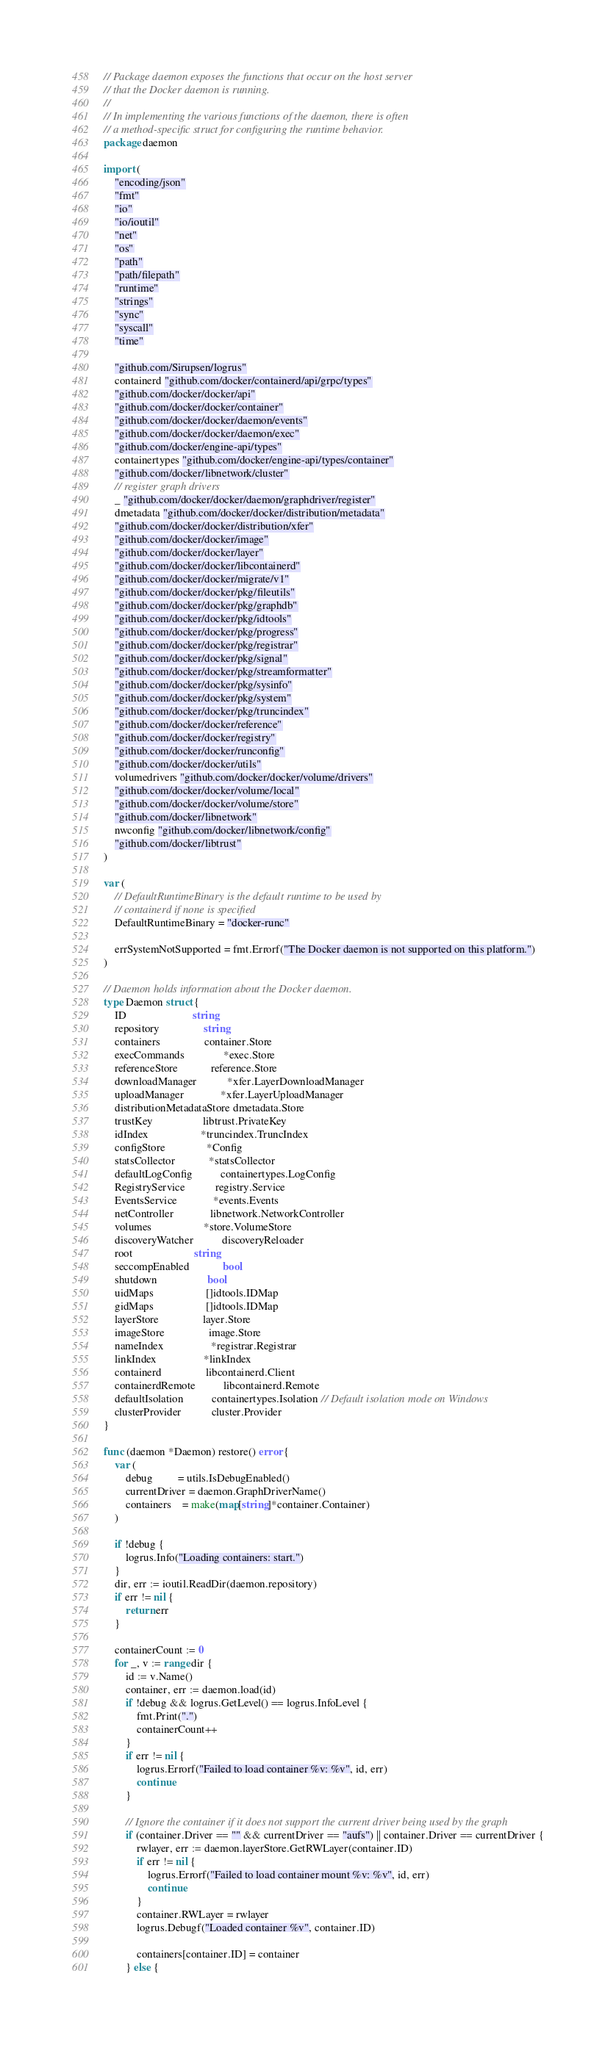<code> <loc_0><loc_0><loc_500><loc_500><_Go_>// Package daemon exposes the functions that occur on the host server
// that the Docker daemon is running.
//
// In implementing the various functions of the daemon, there is often
// a method-specific struct for configuring the runtime behavior.
package daemon

import (
	"encoding/json"
	"fmt"
	"io"
	"io/ioutil"
	"net"
	"os"
	"path"
	"path/filepath"
	"runtime"
	"strings"
	"sync"
	"syscall"
	"time"

	"github.com/Sirupsen/logrus"
	containerd "github.com/docker/containerd/api/grpc/types"
	"github.com/docker/docker/api"
	"github.com/docker/docker/container"
	"github.com/docker/docker/daemon/events"
	"github.com/docker/docker/daemon/exec"
	"github.com/docker/engine-api/types"
	containertypes "github.com/docker/engine-api/types/container"
	"github.com/docker/libnetwork/cluster"
	// register graph drivers
	_ "github.com/docker/docker/daemon/graphdriver/register"
	dmetadata "github.com/docker/docker/distribution/metadata"
	"github.com/docker/docker/distribution/xfer"
	"github.com/docker/docker/image"
	"github.com/docker/docker/layer"
	"github.com/docker/docker/libcontainerd"
	"github.com/docker/docker/migrate/v1"
	"github.com/docker/docker/pkg/fileutils"
	"github.com/docker/docker/pkg/graphdb"
	"github.com/docker/docker/pkg/idtools"
	"github.com/docker/docker/pkg/progress"
	"github.com/docker/docker/pkg/registrar"
	"github.com/docker/docker/pkg/signal"
	"github.com/docker/docker/pkg/streamformatter"
	"github.com/docker/docker/pkg/sysinfo"
	"github.com/docker/docker/pkg/system"
	"github.com/docker/docker/pkg/truncindex"
	"github.com/docker/docker/reference"
	"github.com/docker/docker/registry"
	"github.com/docker/docker/runconfig"
	"github.com/docker/docker/utils"
	volumedrivers "github.com/docker/docker/volume/drivers"
	"github.com/docker/docker/volume/local"
	"github.com/docker/docker/volume/store"
	"github.com/docker/libnetwork"
	nwconfig "github.com/docker/libnetwork/config"
	"github.com/docker/libtrust"
)

var (
	// DefaultRuntimeBinary is the default runtime to be used by
	// containerd if none is specified
	DefaultRuntimeBinary = "docker-runc"

	errSystemNotSupported = fmt.Errorf("The Docker daemon is not supported on this platform.")
)

// Daemon holds information about the Docker daemon.
type Daemon struct {
	ID                        string
	repository                string
	containers                container.Store
	execCommands              *exec.Store
	referenceStore            reference.Store
	downloadManager           *xfer.LayerDownloadManager
	uploadManager             *xfer.LayerUploadManager
	distributionMetadataStore dmetadata.Store
	trustKey                  libtrust.PrivateKey
	idIndex                   *truncindex.TruncIndex
	configStore               *Config
	statsCollector            *statsCollector
	defaultLogConfig          containertypes.LogConfig
	RegistryService           registry.Service
	EventsService             *events.Events
	netController             libnetwork.NetworkController
	volumes                   *store.VolumeStore
	discoveryWatcher          discoveryReloader
	root                      string
	seccompEnabled            bool
	shutdown                  bool
	uidMaps                   []idtools.IDMap
	gidMaps                   []idtools.IDMap
	layerStore                layer.Store
	imageStore                image.Store
	nameIndex                 *registrar.Registrar
	linkIndex                 *linkIndex
	containerd                libcontainerd.Client
	containerdRemote          libcontainerd.Remote
	defaultIsolation          containertypes.Isolation // Default isolation mode on Windows
	clusterProvider           cluster.Provider
}

func (daemon *Daemon) restore() error {
	var (
		debug         = utils.IsDebugEnabled()
		currentDriver = daemon.GraphDriverName()
		containers    = make(map[string]*container.Container)
	)

	if !debug {
		logrus.Info("Loading containers: start.")
	}
	dir, err := ioutil.ReadDir(daemon.repository)
	if err != nil {
		return err
	}

	containerCount := 0
	for _, v := range dir {
		id := v.Name()
		container, err := daemon.load(id)
		if !debug && logrus.GetLevel() == logrus.InfoLevel {
			fmt.Print(".")
			containerCount++
		}
		if err != nil {
			logrus.Errorf("Failed to load container %v: %v", id, err)
			continue
		}

		// Ignore the container if it does not support the current driver being used by the graph
		if (container.Driver == "" && currentDriver == "aufs") || container.Driver == currentDriver {
			rwlayer, err := daemon.layerStore.GetRWLayer(container.ID)
			if err != nil {
				logrus.Errorf("Failed to load container mount %v: %v", id, err)
				continue
			}
			container.RWLayer = rwlayer
			logrus.Debugf("Loaded container %v", container.ID)

			containers[container.ID] = container
		} else {</code> 